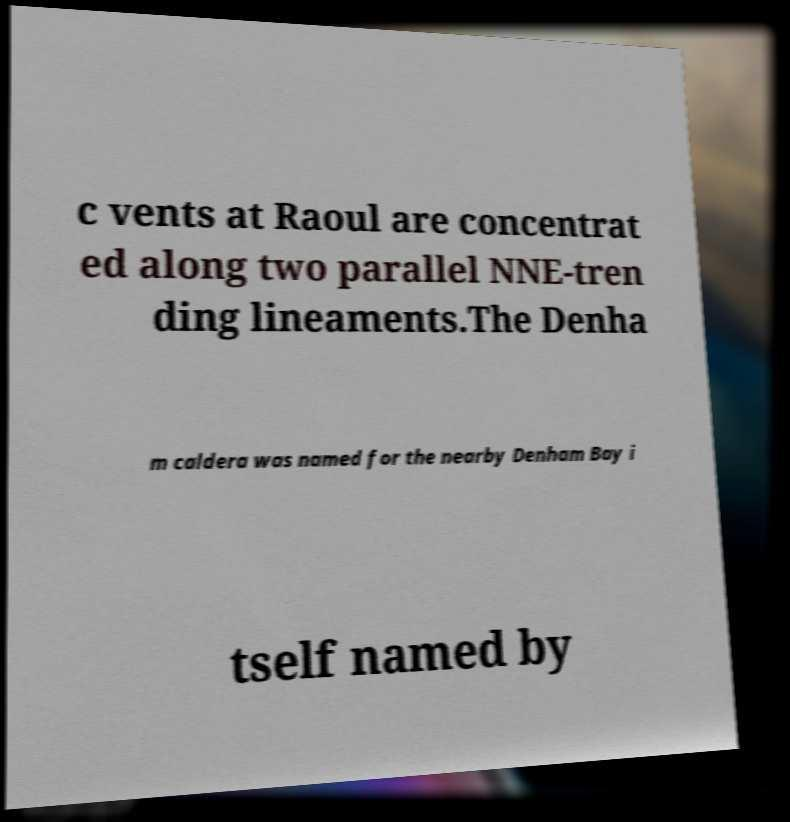There's text embedded in this image that I need extracted. Can you transcribe it verbatim? c vents at Raoul are concentrat ed along two parallel NNE-tren ding lineaments.The Denha m caldera was named for the nearby Denham Bay i tself named by 